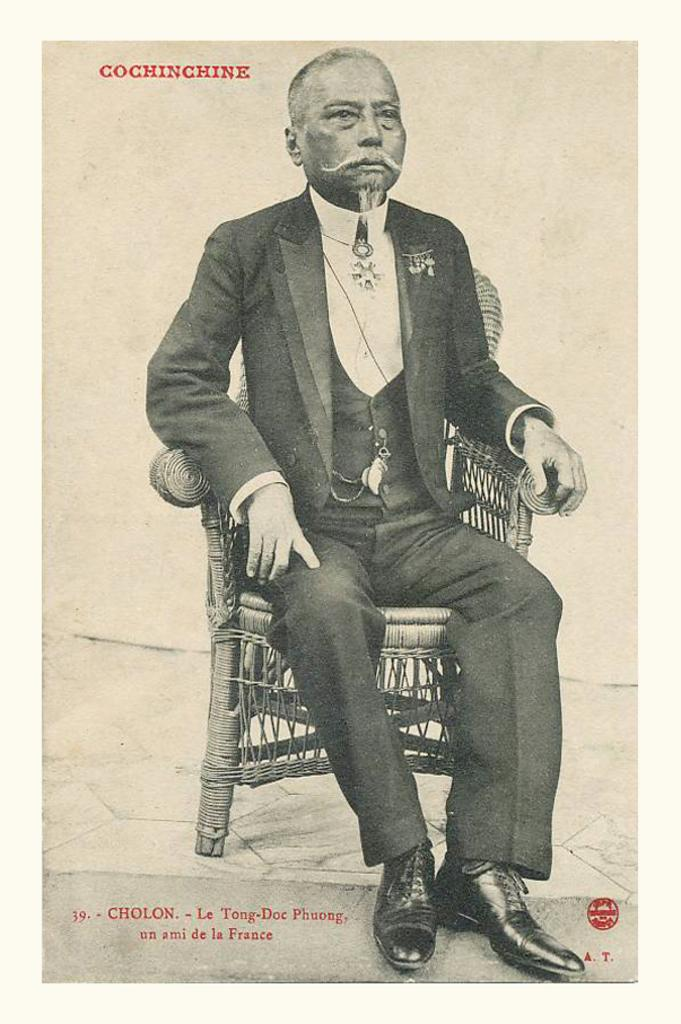What is the main subject of the image? The main subject of the image is a cover page. What can be found on the cover page? The cover page contains text. Is there anyone else in the image besides the cover page? Yes, there is a man in the image. What is the man doing in the image? The man is seated on a chair. What is the taste of the can on the cover page? There is no can present on the cover page, and therefore no taste can be determined. 